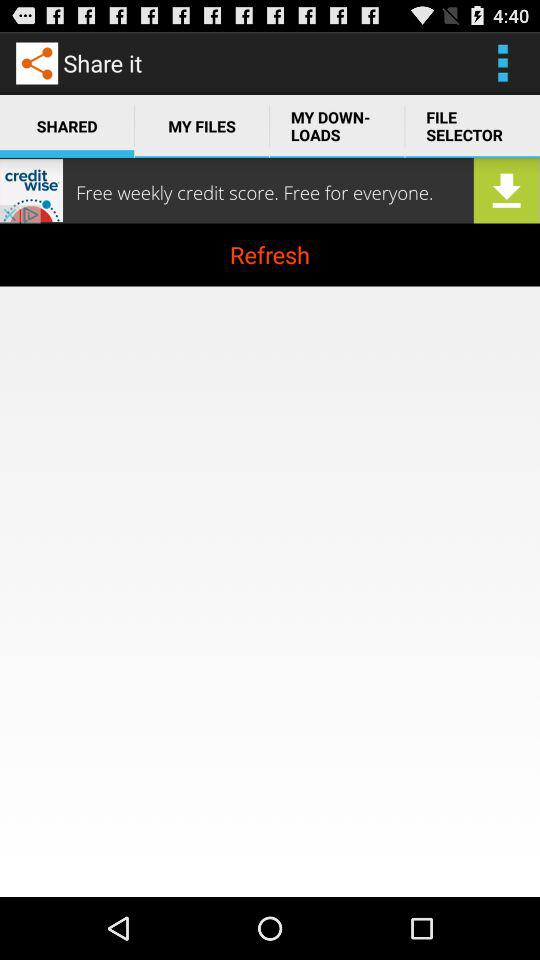Which tab is selected? The selected tab is "SHARED". 